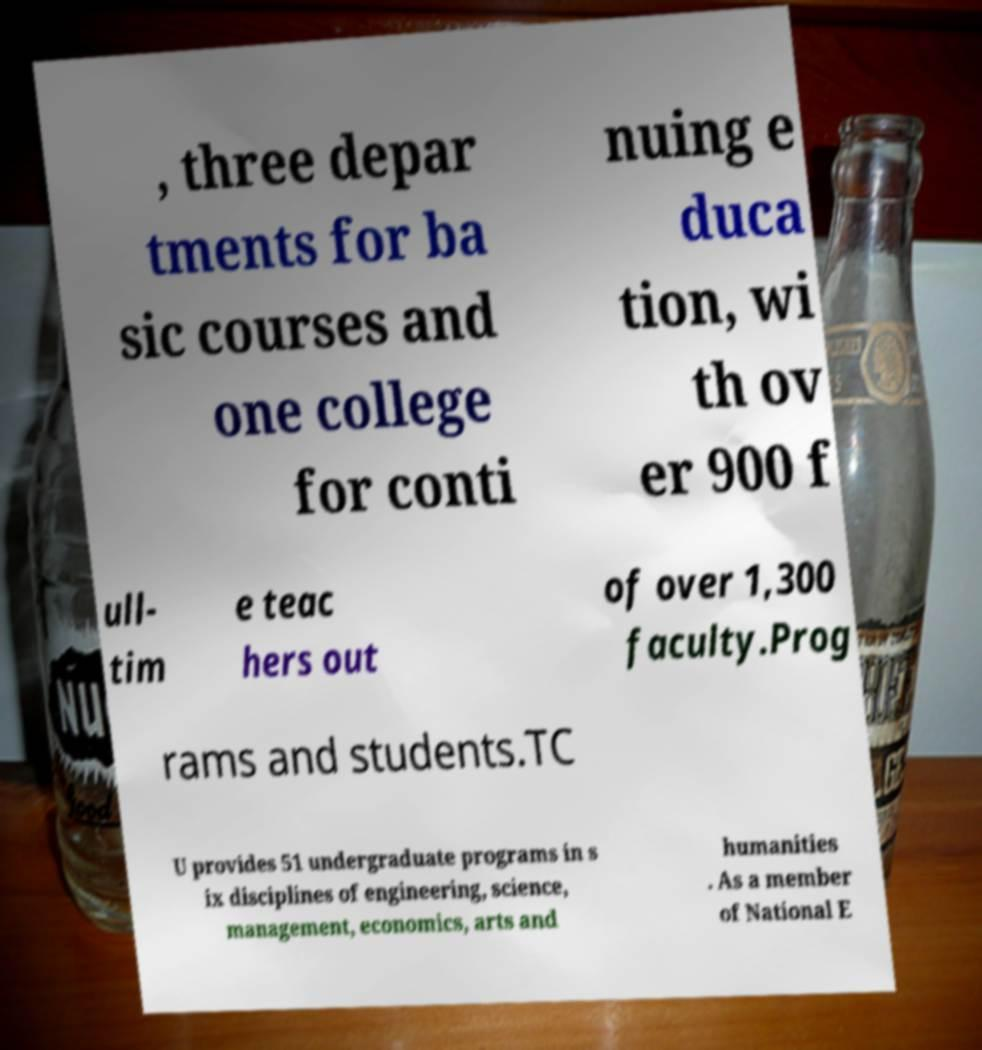There's text embedded in this image that I need extracted. Can you transcribe it verbatim? , three depar tments for ba sic courses and one college for conti nuing e duca tion, wi th ov er 900 f ull- tim e teac hers out of over 1,300 faculty.Prog rams and students.TC U provides 51 undergraduate programs in s ix disciplines of engineering, science, management, economics, arts and humanities . As a member of National E 